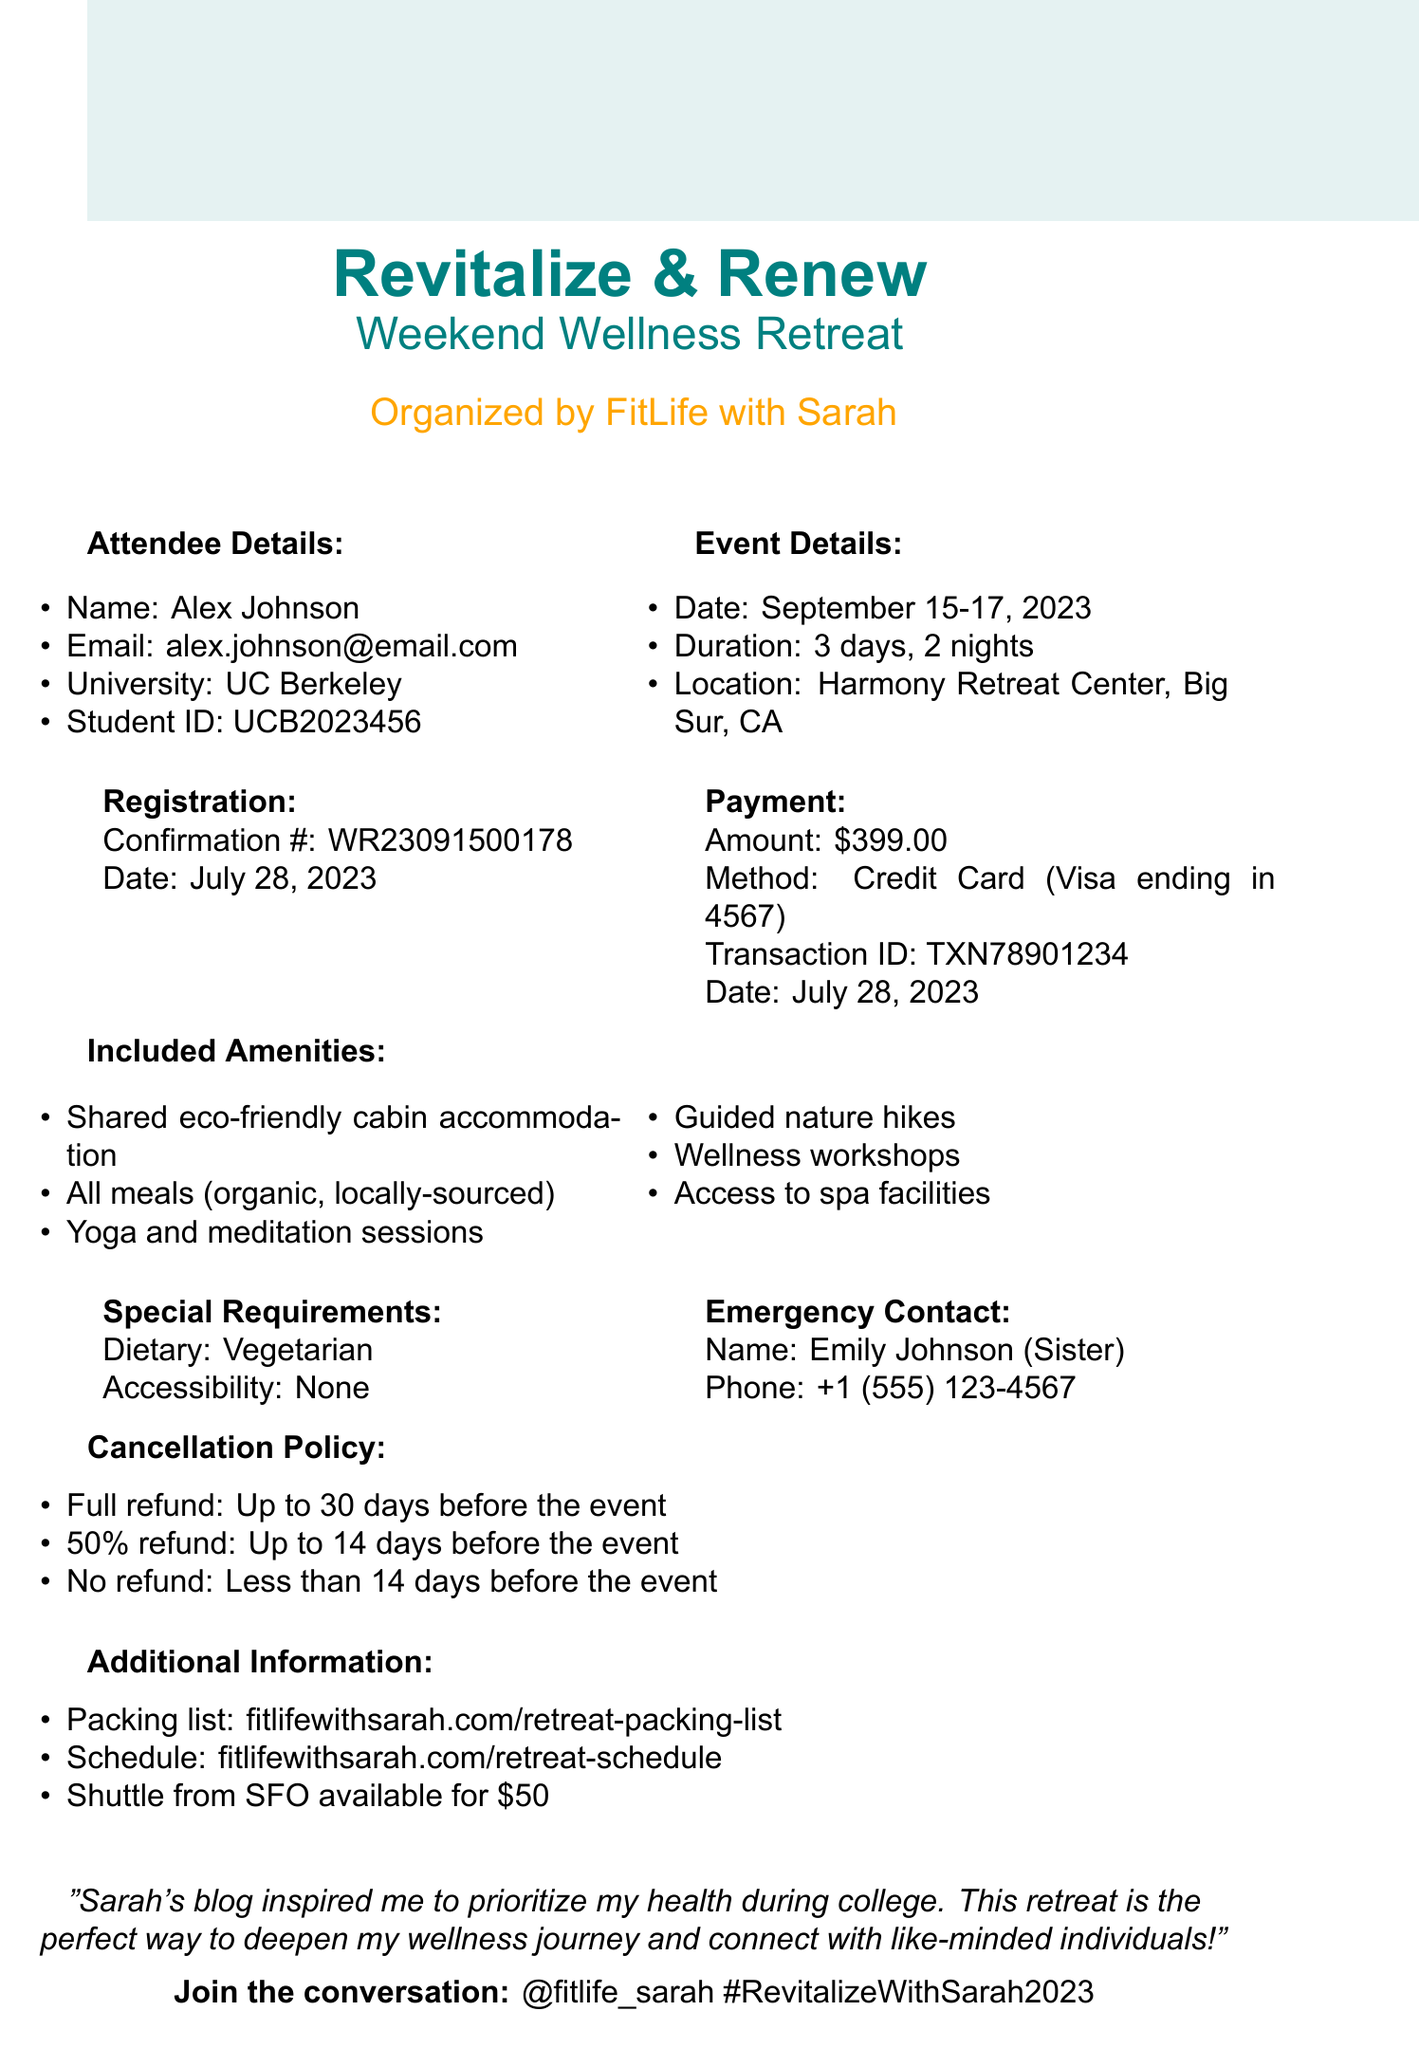What is the event name? The event name is listed at the top of the document, indicating the focus of the gathering.
Answer: Revitalize & Renew: Weekend Wellness Retreat Who is the organizer of the retreat? The organizer is mentioned directly under the event name, showcasing who is hosting the event.
Answer: FitLife with Sarah What is the total cost to attend the retreat? The total cost is detailed in the payment section of the document, indicating the fee for the event.
Answer: $399.00 What is the confirmation number for registration? The confirmation number is provided in the registration section, serving as a unique identifier for the attendee's registration.
Answer: WR23091500178 When was the payment made? The document includes the specific date of the payment in the payment section, reflecting when the transaction occurred.
Answer: July 28, 2023 What amenities are included in the retreat? The document lists various amenities included in the retreat, highlighting what attendees can expect.
Answer: Shared accommodation in eco-friendly cabins, All meals (organic, locally-sourced), Yoga and meditation sessions, Guided nature hikes, Wellness workshops, Access to spa facilities What is the cancellation policy for the event? The cancellation policy is detailed in its own section, outlining the terms for refunds based on timing.
Answer: Full refund: Up to 30 days before the event, 50% refund: Up to 14 days before the event, No refund: Less than 14 days before the event Who can be contacted in case of an emergency? The emergency contact information is specified in the document, providing a point of contact for any urgent situations.
Answer: Emily Johnson Is there a transportation option mentioned? The document includes additional information on transportation options, specifying the available service from an airport.
Answer: Shuttle service available from San Francisco International Airport (SFO) for an additional fee of $50 